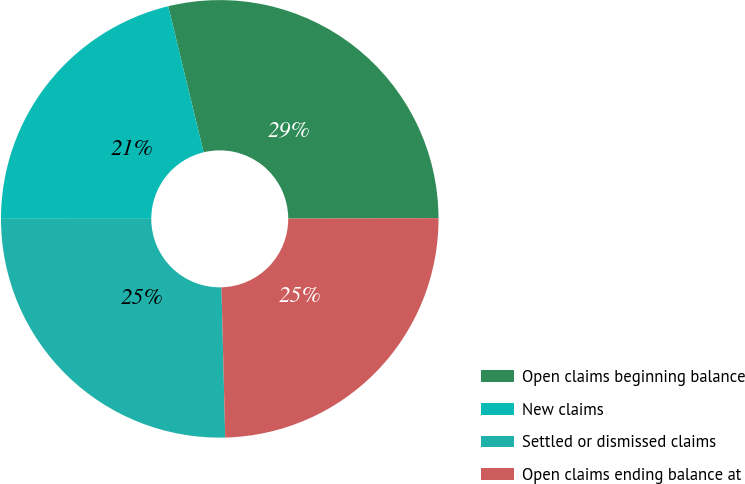<chart> <loc_0><loc_0><loc_500><loc_500><pie_chart><fcel>Open claims beginning balance<fcel>New claims<fcel>Settled or dismissed claims<fcel>Open claims ending balance at<nl><fcel>28.73%<fcel>21.21%<fcel>25.4%<fcel>24.65%<nl></chart> 